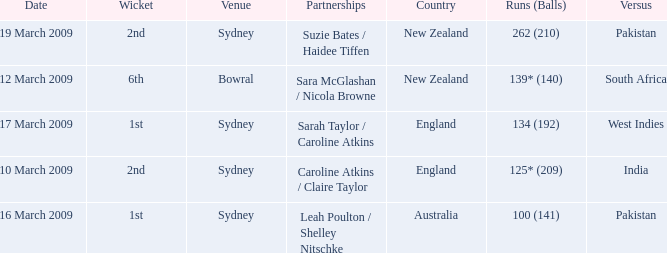What are the dates where the versus team is South Africa? 12 March 2009. 